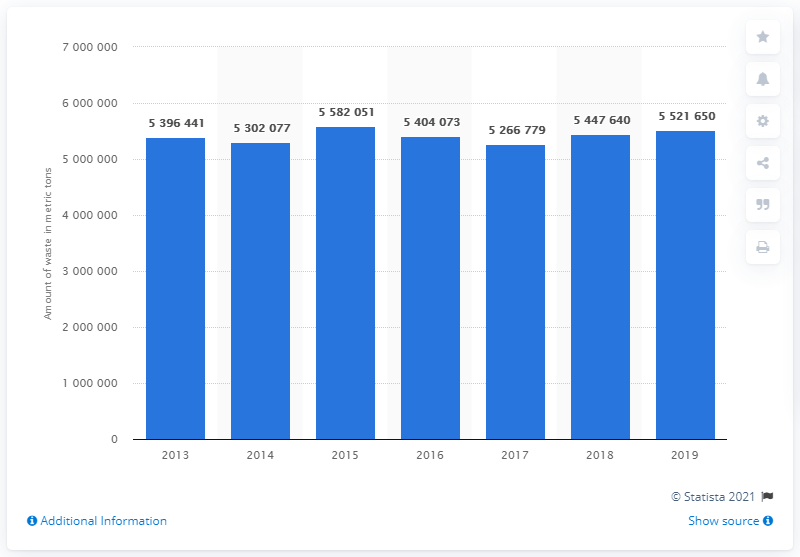Give some essential details in this illustration. In 2019, a total of 552,1650 metric tons of municipal waste was incinerated in Italy. 